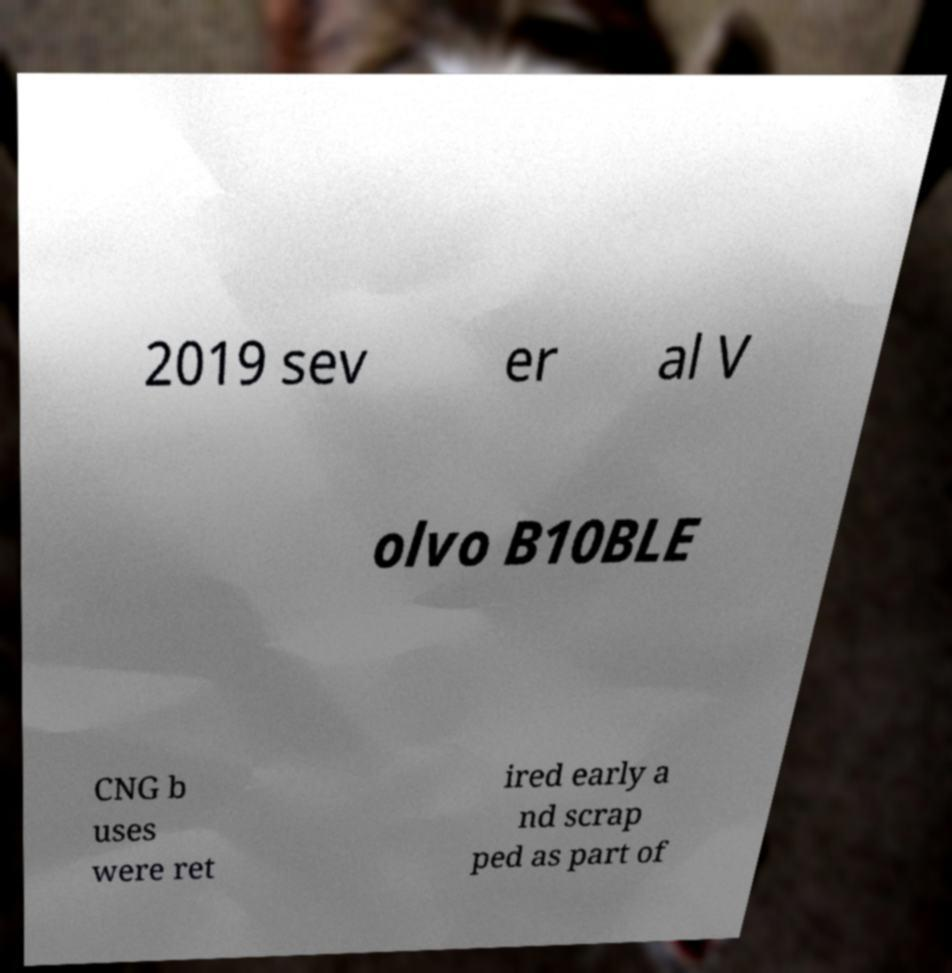There's text embedded in this image that I need extracted. Can you transcribe it verbatim? 2019 sev er al V olvo B10BLE CNG b uses were ret ired early a nd scrap ped as part of 